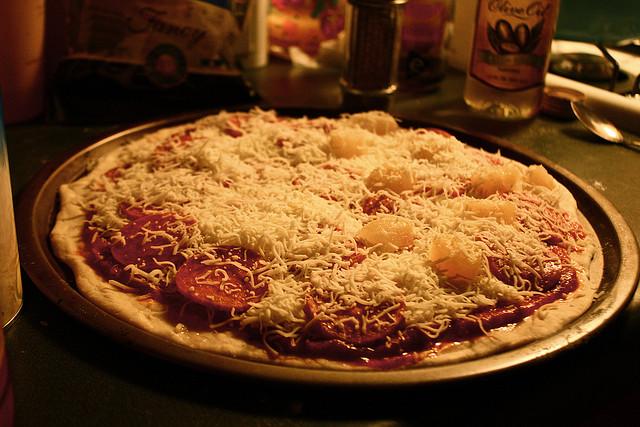Is there a boat on the pizza?
Write a very short answer. No. Does the pizza look delicious?
Concise answer only. Yes. Is this a square deep dish pizza?
Give a very brief answer. No. What condiment was used to decorate the food?
Be succinct. Cheese. 